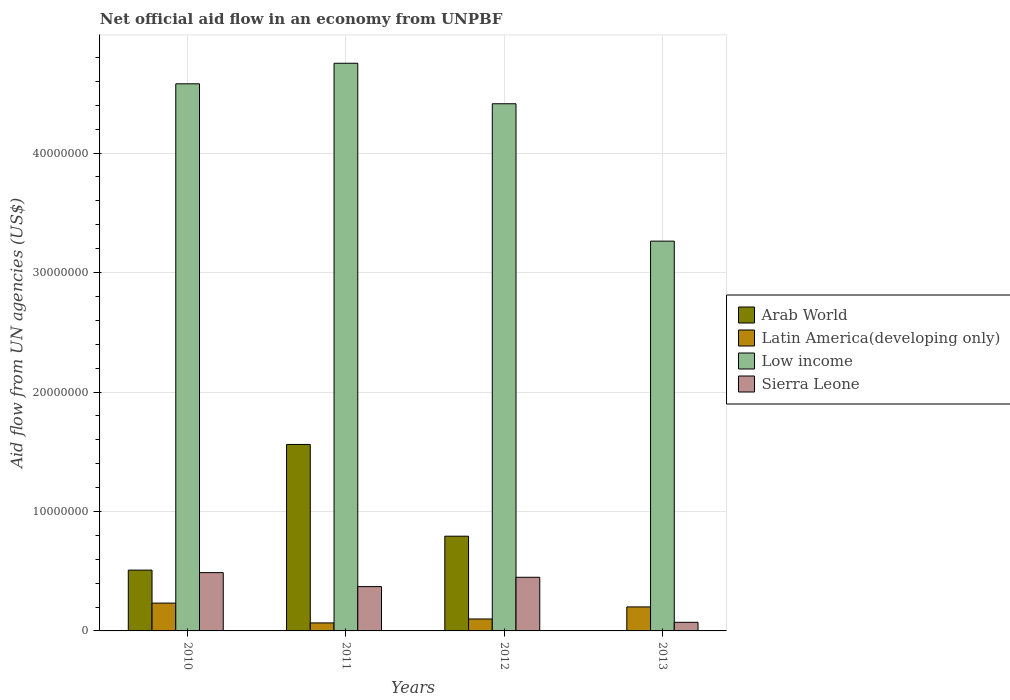How many different coloured bars are there?
Make the answer very short. 4. How many groups of bars are there?
Offer a terse response. 4. Are the number of bars on each tick of the X-axis equal?
Keep it short and to the point. No. What is the label of the 2nd group of bars from the left?
Keep it short and to the point. 2011. What is the net official aid flow in Sierra Leone in 2012?
Offer a terse response. 4.49e+06. Across all years, what is the maximum net official aid flow in Sierra Leone?
Keep it short and to the point. 4.88e+06. In which year was the net official aid flow in Arab World maximum?
Provide a succinct answer. 2011. What is the total net official aid flow in Arab World in the graph?
Make the answer very short. 2.86e+07. What is the difference between the net official aid flow in Latin America(developing only) in 2012 and that in 2013?
Provide a succinct answer. -1.01e+06. What is the difference between the net official aid flow in Low income in 2012 and the net official aid flow in Latin America(developing only) in 2013?
Keep it short and to the point. 4.21e+07. What is the average net official aid flow in Arab World per year?
Keep it short and to the point. 7.16e+06. In the year 2012, what is the difference between the net official aid flow in Sierra Leone and net official aid flow in Arab World?
Give a very brief answer. -3.44e+06. In how many years, is the net official aid flow in Sierra Leone greater than 18000000 US$?
Keep it short and to the point. 0. What is the ratio of the net official aid flow in Low income in 2010 to that in 2011?
Make the answer very short. 0.96. Is the difference between the net official aid flow in Sierra Leone in 2010 and 2012 greater than the difference between the net official aid flow in Arab World in 2010 and 2012?
Offer a very short reply. Yes. What is the difference between the highest and the second highest net official aid flow in Low income?
Your answer should be very brief. 1.72e+06. What is the difference between the highest and the lowest net official aid flow in Arab World?
Your answer should be compact. 1.56e+07. Is the sum of the net official aid flow in Arab World in 2011 and 2012 greater than the maximum net official aid flow in Sierra Leone across all years?
Provide a succinct answer. Yes. Is it the case that in every year, the sum of the net official aid flow in Arab World and net official aid flow in Low income is greater than the sum of net official aid flow in Sierra Leone and net official aid flow in Latin America(developing only)?
Your answer should be compact. Yes. How many bars are there?
Offer a terse response. 15. How many years are there in the graph?
Provide a succinct answer. 4. Are the values on the major ticks of Y-axis written in scientific E-notation?
Ensure brevity in your answer.  No. How many legend labels are there?
Your response must be concise. 4. How are the legend labels stacked?
Your response must be concise. Vertical. What is the title of the graph?
Your response must be concise. Net official aid flow in an economy from UNPBF. Does "Fiji" appear as one of the legend labels in the graph?
Your response must be concise. No. What is the label or title of the X-axis?
Your answer should be compact. Years. What is the label or title of the Y-axis?
Make the answer very short. Aid flow from UN agencies (US$). What is the Aid flow from UN agencies (US$) in Arab World in 2010?
Offer a very short reply. 5.09e+06. What is the Aid flow from UN agencies (US$) in Latin America(developing only) in 2010?
Provide a succinct answer. 2.33e+06. What is the Aid flow from UN agencies (US$) of Low income in 2010?
Your answer should be compact. 4.58e+07. What is the Aid flow from UN agencies (US$) in Sierra Leone in 2010?
Provide a short and direct response. 4.88e+06. What is the Aid flow from UN agencies (US$) of Arab World in 2011?
Your response must be concise. 1.56e+07. What is the Aid flow from UN agencies (US$) in Latin America(developing only) in 2011?
Your answer should be compact. 6.70e+05. What is the Aid flow from UN agencies (US$) in Low income in 2011?
Offer a very short reply. 4.75e+07. What is the Aid flow from UN agencies (US$) of Sierra Leone in 2011?
Give a very brief answer. 3.71e+06. What is the Aid flow from UN agencies (US$) of Arab World in 2012?
Make the answer very short. 7.93e+06. What is the Aid flow from UN agencies (US$) of Low income in 2012?
Your answer should be very brief. 4.41e+07. What is the Aid flow from UN agencies (US$) in Sierra Leone in 2012?
Your answer should be very brief. 4.49e+06. What is the Aid flow from UN agencies (US$) of Latin America(developing only) in 2013?
Your response must be concise. 2.01e+06. What is the Aid flow from UN agencies (US$) in Low income in 2013?
Provide a succinct answer. 3.26e+07. What is the Aid flow from UN agencies (US$) of Sierra Leone in 2013?
Keep it short and to the point. 7.20e+05. Across all years, what is the maximum Aid flow from UN agencies (US$) of Arab World?
Provide a short and direct response. 1.56e+07. Across all years, what is the maximum Aid flow from UN agencies (US$) of Latin America(developing only)?
Keep it short and to the point. 2.33e+06. Across all years, what is the maximum Aid flow from UN agencies (US$) in Low income?
Ensure brevity in your answer.  4.75e+07. Across all years, what is the maximum Aid flow from UN agencies (US$) in Sierra Leone?
Your answer should be compact. 4.88e+06. Across all years, what is the minimum Aid flow from UN agencies (US$) in Arab World?
Keep it short and to the point. 0. Across all years, what is the minimum Aid flow from UN agencies (US$) in Latin America(developing only)?
Keep it short and to the point. 6.70e+05. Across all years, what is the minimum Aid flow from UN agencies (US$) in Low income?
Your answer should be compact. 3.26e+07. Across all years, what is the minimum Aid flow from UN agencies (US$) of Sierra Leone?
Your answer should be compact. 7.20e+05. What is the total Aid flow from UN agencies (US$) in Arab World in the graph?
Give a very brief answer. 2.86e+07. What is the total Aid flow from UN agencies (US$) in Latin America(developing only) in the graph?
Keep it short and to the point. 6.01e+06. What is the total Aid flow from UN agencies (US$) in Low income in the graph?
Offer a terse response. 1.70e+08. What is the total Aid flow from UN agencies (US$) in Sierra Leone in the graph?
Ensure brevity in your answer.  1.38e+07. What is the difference between the Aid flow from UN agencies (US$) in Arab World in 2010 and that in 2011?
Offer a terse response. -1.05e+07. What is the difference between the Aid flow from UN agencies (US$) of Latin America(developing only) in 2010 and that in 2011?
Give a very brief answer. 1.66e+06. What is the difference between the Aid flow from UN agencies (US$) of Low income in 2010 and that in 2011?
Keep it short and to the point. -1.72e+06. What is the difference between the Aid flow from UN agencies (US$) in Sierra Leone in 2010 and that in 2011?
Give a very brief answer. 1.17e+06. What is the difference between the Aid flow from UN agencies (US$) of Arab World in 2010 and that in 2012?
Your answer should be compact. -2.84e+06. What is the difference between the Aid flow from UN agencies (US$) of Latin America(developing only) in 2010 and that in 2012?
Offer a very short reply. 1.33e+06. What is the difference between the Aid flow from UN agencies (US$) of Low income in 2010 and that in 2012?
Make the answer very short. 1.67e+06. What is the difference between the Aid flow from UN agencies (US$) in Low income in 2010 and that in 2013?
Your response must be concise. 1.32e+07. What is the difference between the Aid flow from UN agencies (US$) in Sierra Leone in 2010 and that in 2013?
Give a very brief answer. 4.16e+06. What is the difference between the Aid flow from UN agencies (US$) of Arab World in 2011 and that in 2012?
Ensure brevity in your answer.  7.68e+06. What is the difference between the Aid flow from UN agencies (US$) of Latin America(developing only) in 2011 and that in 2012?
Make the answer very short. -3.30e+05. What is the difference between the Aid flow from UN agencies (US$) in Low income in 2011 and that in 2012?
Offer a very short reply. 3.39e+06. What is the difference between the Aid flow from UN agencies (US$) in Sierra Leone in 2011 and that in 2012?
Give a very brief answer. -7.80e+05. What is the difference between the Aid flow from UN agencies (US$) in Latin America(developing only) in 2011 and that in 2013?
Offer a terse response. -1.34e+06. What is the difference between the Aid flow from UN agencies (US$) in Low income in 2011 and that in 2013?
Keep it short and to the point. 1.49e+07. What is the difference between the Aid flow from UN agencies (US$) of Sierra Leone in 2011 and that in 2013?
Provide a succinct answer. 2.99e+06. What is the difference between the Aid flow from UN agencies (US$) of Latin America(developing only) in 2012 and that in 2013?
Offer a very short reply. -1.01e+06. What is the difference between the Aid flow from UN agencies (US$) in Low income in 2012 and that in 2013?
Give a very brief answer. 1.15e+07. What is the difference between the Aid flow from UN agencies (US$) of Sierra Leone in 2012 and that in 2013?
Offer a terse response. 3.77e+06. What is the difference between the Aid flow from UN agencies (US$) of Arab World in 2010 and the Aid flow from UN agencies (US$) of Latin America(developing only) in 2011?
Ensure brevity in your answer.  4.42e+06. What is the difference between the Aid flow from UN agencies (US$) in Arab World in 2010 and the Aid flow from UN agencies (US$) in Low income in 2011?
Provide a succinct answer. -4.24e+07. What is the difference between the Aid flow from UN agencies (US$) in Arab World in 2010 and the Aid flow from UN agencies (US$) in Sierra Leone in 2011?
Your answer should be very brief. 1.38e+06. What is the difference between the Aid flow from UN agencies (US$) of Latin America(developing only) in 2010 and the Aid flow from UN agencies (US$) of Low income in 2011?
Keep it short and to the point. -4.52e+07. What is the difference between the Aid flow from UN agencies (US$) of Latin America(developing only) in 2010 and the Aid flow from UN agencies (US$) of Sierra Leone in 2011?
Your answer should be compact. -1.38e+06. What is the difference between the Aid flow from UN agencies (US$) of Low income in 2010 and the Aid flow from UN agencies (US$) of Sierra Leone in 2011?
Keep it short and to the point. 4.21e+07. What is the difference between the Aid flow from UN agencies (US$) in Arab World in 2010 and the Aid flow from UN agencies (US$) in Latin America(developing only) in 2012?
Your answer should be compact. 4.09e+06. What is the difference between the Aid flow from UN agencies (US$) in Arab World in 2010 and the Aid flow from UN agencies (US$) in Low income in 2012?
Your answer should be compact. -3.90e+07. What is the difference between the Aid flow from UN agencies (US$) of Arab World in 2010 and the Aid flow from UN agencies (US$) of Sierra Leone in 2012?
Make the answer very short. 6.00e+05. What is the difference between the Aid flow from UN agencies (US$) of Latin America(developing only) in 2010 and the Aid flow from UN agencies (US$) of Low income in 2012?
Offer a terse response. -4.18e+07. What is the difference between the Aid flow from UN agencies (US$) of Latin America(developing only) in 2010 and the Aid flow from UN agencies (US$) of Sierra Leone in 2012?
Ensure brevity in your answer.  -2.16e+06. What is the difference between the Aid flow from UN agencies (US$) in Low income in 2010 and the Aid flow from UN agencies (US$) in Sierra Leone in 2012?
Offer a very short reply. 4.13e+07. What is the difference between the Aid flow from UN agencies (US$) of Arab World in 2010 and the Aid flow from UN agencies (US$) of Latin America(developing only) in 2013?
Give a very brief answer. 3.08e+06. What is the difference between the Aid flow from UN agencies (US$) in Arab World in 2010 and the Aid flow from UN agencies (US$) in Low income in 2013?
Your answer should be very brief. -2.75e+07. What is the difference between the Aid flow from UN agencies (US$) in Arab World in 2010 and the Aid flow from UN agencies (US$) in Sierra Leone in 2013?
Provide a short and direct response. 4.37e+06. What is the difference between the Aid flow from UN agencies (US$) in Latin America(developing only) in 2010 and the Aid flow from UN agencies (US$) in Low income in 2013?
Provide a short and direct response. -3.03e+07. What is the difference between the Aid flow from UN agencies (US$) of Latin America(developing only) in 2010 and the Aid flow from UN agencies (US$) of Sierra Leone in 2013?
Offer a very short reply. 1.61e+06. What is the difference between the Aid flow from UN agencies (US$) in Low income in 2010 and the Aid flow from UN agencies (US$) in Sierra Leone in 2013?
Provide a short and direct response. 4.51e+07. What is the difference between the Aid flow from UN agencies (US$) of Arab World in 2011 and the Aid flow from UN agencies (US$) of Latin America(developing only) in 2012?
Your answer should be very brief. 1.46e+07. What is the difference between the Aid flow from UN agencies (US$) in Arab World in 2011 and the Aid flow from UN agencies (US$) in Low income in 2012?
Provide a short and direct response. -2.85e+07. What is the difference between the Aid flow from UN agencies (US$) in Arab World in 2011 and the Aid flow from UN agencies (US$) in Sierra Leone in 2012?
Give a very brief answer. 1.11e+07. What is the difference between the Aid flow from UN agencies (US$) of Latin America(developing only) in 2011 and the Aid flow from UN agencies (US$) of Low income in 2012?
Offer a very short reply. -4.35e+07. What is the difference between the Aid flow from UN agencies (US$) in Latin America(developing only) in 2011 and the Aid flow from UN agencies (US$) in Sierra Leone in 2012?
Keep it short and to the point. -3.82e+06. What is the difference between the Aid flow from UN agencies (US$) in Low income in 2011 and the Aid flow from UN agencies (US$) in Sierra Leone in 2012?
Offer a very short reply. 4.30e+07. What is the difference between the Aid flow from UN agencies (US$) of Arab World in 2011 and the Aid flow from UN agencies (US$) of Latin America(developing only) in 2013?
Make the answer very short. 1.36e+07. What is the difference between the Aid flow from UN agencies (US$) of Arab World in 2011 and the Aid flow from UN agencies (US$) of Low income in 2013?
Keep it short and to the point. -1.70e+07. What is the difference between the Aid flow from UN agencies (US$) in Arab World in 2011 and the Aid flow from UN agencies (US$) in Sierra Leone in 2013?
Provide a succinct answer. 1.49e+07. What is the difference between the Aid flow from UN agencies (US$) in Latin America(developing only) in 2011 and the Aid flow from UN agencies (US$) in Low income in 2013?
Ensure brevity in your answer.  -3.20e+07. What is the difference between the Aid flow from UN agencies (US$) in Low income in 2011 and the Aid flow from UN agencies (US$) in Sierra Leone in 2013?
Your response must be concise. 4.68e+07. What is the difference between the Aid flow from UN agencies (US$) of Arab World in 2012 and the Aid flow from UN agencies (US$) of Latin America(developing only) in 2013?
Provide a succinct answer. 5.92e+06. What is the difference between the Aid flow from UN agencies (US$) in Arab World in 2012 and the Aid flow from UN agencies (US$) in Low income in 2013?
Keep it short and to the point. -2.47e+07. What is the difference between the Aid flow from UN agencies (US$) in Arab World in 2012 and the Aid flow from UN agencies (US$) in Sierra Leone in 2013?
Keep it short and to the point. 7.21e+06. What is the difference between the Aid flow from UN agencies (US$) of Latin America(developing only) in 2012 and the Aid flow from UN agencies (US$) of Low income in 2013?
Your answer should be very brief. -3.16e+07. What is the difference between the Aid flow from UN agencies (US$) of Low income in 2012 and the Aid flow from UN agencies (US$) of Sierra Leone in 2013?
Make the answer very short. 4.34e+07. What is the average Aid flow from UN agencies (US$) of Arab World per year?
Give a very brief answer. 7.16e+06. What is the average Aid flow from UN agencies (US$) of Latin America(developing only) per year?
Give a very brief answer. 1.50e+06. What is the average Aid flow from UN agencies (US$) in Low income per year?
Provide a short and direct response. 4.25e+07. What is the average Aid flow from UN agencies (US$) of Sierra Leone per year?
Make the answer very short. 3.45e+06. In the year 2010, what is the difference between the Aid flow from UN agencies (US$) in Arab World and Aid flow from UN agencies (US$) in Latin America(developing only)?
Make the answer very short. 2.76e+06. In the year 2010, what is the difference between the Aid flow from UN agencies (US$) of Arab World and Aid flow from UN agencies (US$) of Low income?
Offer a terse response. -4.07e+07. In the year 2010, what is the difference between the Aid flow from UN agencies (US$) in Latin America(developing only) and Aid flow from UN agencies (US$) in Low income?
Provide a succinct answer. -4.35e+07. In the year 2010, what is the difference between the Aid flow from UN agencies (US$) of Latin America(developing only) and Aid flow from UN agencies (US$) of Sierra Leone?
Your answer should be very brief. -2.55e+06. In the year 2010, what is the difference between the Aid flow from UN agencies (US$) of Low income and Aid flow from UN agencies (US$) of Sierra Leone?
Give a very brief answer. 4.09e+07. In the year 2011, what is the difference between the Aid flow from UN agencies (US$) in Arab World and Aid flow from UN agencies (US$) in Latin America(developing only)?
Ensure brevity in your answer.  1.49e+07. In the year 2011, what is the difference between the Aid flow from UN agencies (US$) in Arab World and Aid flow from UN agencies (US$) in Low income?
Offer a very short reply. -3.19e+07. In the year 2011, what is the difference between the Aid flow from UN agencies (US$) in Arab World and Aid flow from UN agencies (US$) in Sierra Leone?
Keep it short and to the point. 1.19e+07. In the year 2011, what is the difference between the Aid flow from UN agencies (US$) in Latin America(developing only) and Aid flow from UN agencies (US$) in Low income?
Provide a short and direct response. -4.68e+07. In the year 2011, what is the difference between the Aid flow from UN agencies (US$) in Latin America(developing only) and Aid flow from UN agencies (US$) in Sierra Leone?
Provide a succinct answer. -3.04e+06. In the year 2011, what is the difference between the Aid flow from UN agencies (US$) in Low income and Aid flow from UN agencies (US$) in Sierra Leone?
Keep it short and to the point. 4.38e+07. In the year 2012, what is the difference between the Aid flow from UN agencies (US$) of Arab World and Aid flow from UN agencies (US$) of Latin America(developing only)?
Provide a short and direct response. 6.93e+06. In the year 2012, what is the difference between the Aid flow from UN agencies (US$) in Arab World and Aid flow from UN agencies (US$) in Low income?
Provide a short and direct response. -3.62e+07. In the year 2012, what is the difference between the Aid flow from UN agencies (US$) of Arab World and Aid flow from UN agencies (US$) of Sierra Leone?
Your answer should be compact. 3.44e+06. In the year 2012, what is the difference between the Aid flow from UN agencies (US$) in Latin America(developing only) and Aid flow from UN agencies (US$) in Low income?
Provide a succinct answer. -4.31e+07. In the year 2012, what is the difference between the Aid flow from UN agencies (US$) of Latin America(developing only) and Aid flow from UN agencies (US$) of Sierra Leone?
Offer a terse response. -3.49e+06. In the year 2012, what is the difference between the Aid flow from UN agencies (US$) of Low income and Aid flow from UN agencies (US$) of Sierra Leone?
Make the answer very short. 3.96e+07. In the year 2013, what is the difference between the Aid flow from UN agencies (US$) of Latin America(developing only) and Aid flow from UN agencies (US$) of Low income?
Give a very brief answer. -3.06e+07. In the year 2013, what is the difference between the Aid flow from UN agencies (US$) in Latin America(developing only) and Aid flow from UN agencies (US$) in Sierra Leone?
Provide a succinct answer. 1.29e+06. In the year 2013, what is the difference between the Aid flow from UN agencies (US$) in Low income and Aid flow from UN agencies (US$) in Sierra Leone?
Keep it short and to the point. 3.19e+07. What is the ratio of the Aid flow from UN agencies (US$) in Arab World in 2010 to that in 2011?
Your response must be concise. 0.33. What is the ratio of the Aid flow from UN agencies (US$) in Latin America(developing only) in 2010 to that in 2011?
Make the answer very short. 3.48. What is the ratio of the Aid flow from UN agencies (US$) of Low income in 2010 to that in 2011?
Give a very brief answer. 0.96. What is the ratio of the Aid flow from UN agencies (US$) of Sierra Leone in 2010 to that in 2011?
Provide a succinct answer. 1.32. What is the ratio of the Aid flow from UN agencies (US$) in Arab World in 2010 to that in 2012?
Your answer should be very brief. 0.64. What is the ratio of the Aid flow from UN agencies (US$) in Latin America(developing only) in 2010 to that in 2012?
Your response must be concise. 2.33. What is the ratio of the Aid flow from UN agencies (US$) of Low income in 2010 to that in 2012?
Give a very brief answer. 1.04. What is the ratio of the Aid flow from UN agencies (US$) of Sierra Leone in 2010 to that in 2012?
Offer a very short reply. 1.09. What is the ratio of the Aid flow from UN agencies (US$) of Latin America(developing only) in 2010 to that in 2013?
Keep it short and to the point. 1.16. What is the ratio of the Aid flow from UN agencies (US$) of Low income in 2010 to that in 2013?
Your answer should be compact. 1.4. What is the ratio of the Aid flow from UN agencies (US$) in Sierra Leone in 2010 to that in 2013?
Offer a terse response. 6.78. What is the ratio of the Aid flow from UN agencies (US$) in Arab World in 2011 to that in 2012?
Give a very brief answer. 1.97. What is the ratio of the Aid flow from UN agencies (US$) of Latin America(developing only) in 2011 to that in 2012?
Provide a succinct answer. 0.67. What is the ratio of the Aid flow from UN agencies (US$) in Low income in 2011 to that in 2012?
Make the answer very short. 1.08. What is the ratio of the Aid flow from UN agencies (US$) in Sierra Leone in 2011 to that in 2012?
Provide a succinct answer. 0.83. What is the ratio of the Aid flow from UN agencies (US$) in Low income in 2011 to that in 2013?
Offer a very short reply. 1.46. What is the ratio of the Aid flow from UN agencies (US$) in Sierra Leone in 2011 to that in 2013?
Make the answer very short. 5.15. What is the ratio of the Aid flow from UN agencies (US$) of Latin America(developing only) in 2012 to that in 2013?
Your answer should be very brief. 0.5. What is the ratio of the Aid flow from UN agencies (US$) of Low income in 2012 to that in 2013?
Ensure brevity in your answer.  1.35. What is the ratio of the Aid flow from UN agencies (US$) of Sierra Leone in 2012 to that in 2013?
Give a very brief answer. 6.24. What is the difference between the highest and the second highest Aid flow from UN agencies (US$) in Arab World?
Give a very brief answer. 7.68e+06. What is the difference between the highest and the second highest Aid flow from UN agencies (US$) in Latin America(developing only)?
Make the answer very short. 3.20e+05. What is the difference between the highest and the second highest Aid flow from UN agencies (US$) of Low income?
Make the answer very short. 1.72e+06. What is the difference between the highest and the lowest Aid flow from UN agencies (US$) in Arab World?
Your response must be concise. 1.56e+07. What is the difference between the highest and the lowest Aid flow from UN agencies (US$) in Latin America(developing only)?
Provide a succinct answer. 1.66e+06. What is the difference between the highest and the lowest Aid flow from UN agencies (US$) of Low income?
Keep it short and to the point. 1.49e+07. What is the difference between the highest and the lowest Aid flow from UN agencies (US$) of Sierra Leone?
Make the answer very short. 4.16e+06. 